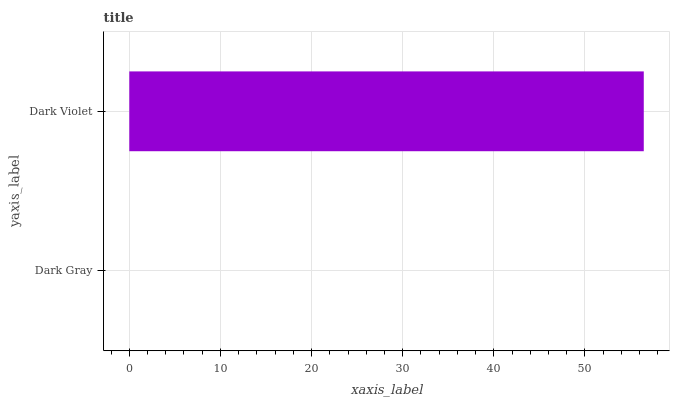Is Dark Gray the minimum?
Answer yes or no. Yes. Is Dark Violet the maximum?
Answer yes or no. Yes. Is Dark Violet the minimum?
Answer yes or no. No. Is Dark Violet greater than Dark Gray?
Answer yes or no. Yes. Is Dark Gray less than Dark Violet?
Answer yes or no. Yes. Is Dark Gray greater than Dark Violet?
Answer yes or no. No. Is Dark Violet less than Dark Gray?
Answer yes or no. No. Is Dark Violet the high median?
Answer yes or no. Yes. Is Dark Gray the low median?
Answer yes or no. Yes. Is Dark Gray the high median?
Answer yes or no. No. Is Dark Violet the low median?
Answer yes or no. No. 